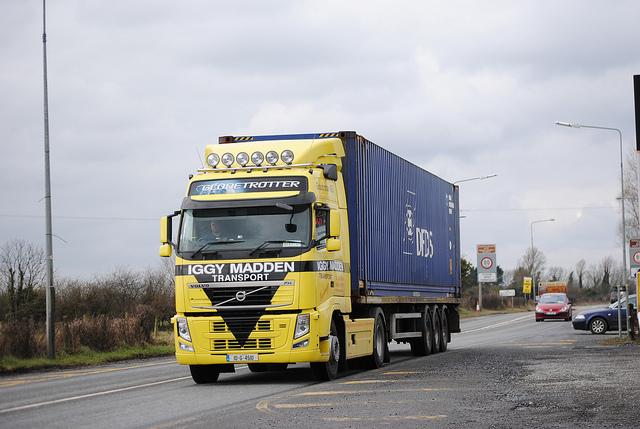What is the name on the front of the truck?
Short answer required. Iggy madden. What color is the truck?
Concise answer only. Yellow. Is that a car?
Concise answer only. No. What company logo is the yellow truck?
Give a very brief answer. Iggy madden. Is the truck traveling on an interstate?
Write a very short answer. No. 